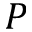<formula> <loc_0><loc_0><loc_500><loc_500>P</formula> 